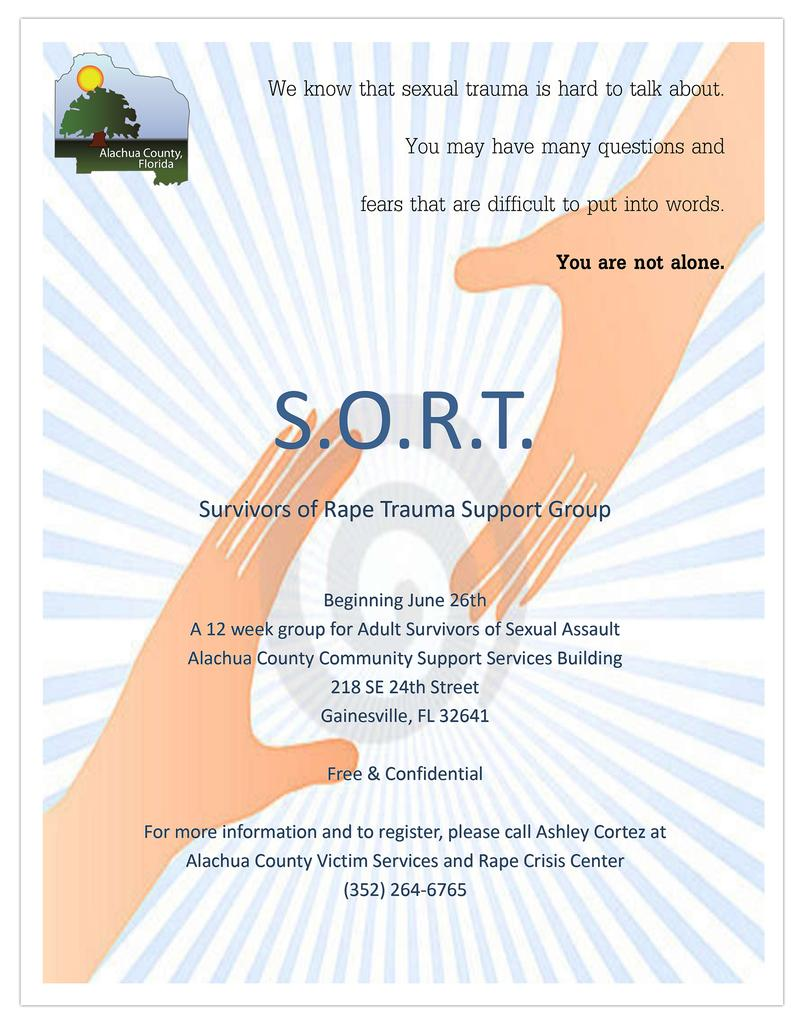What type of visual is the image? The image is a poster. What is featured on the poster besides the text? There is a logo, a watermark, and a picture of hands of a person on the poster. What can be found on the poster in terms of written content? Texts are written on the poster. What type of trail can be seen in the image? There is no trail present in the image; it is a poster with a logo, watermark, texts, and a picture of hands. How many quarters are visible in the image? There are no quarters present in the image. 